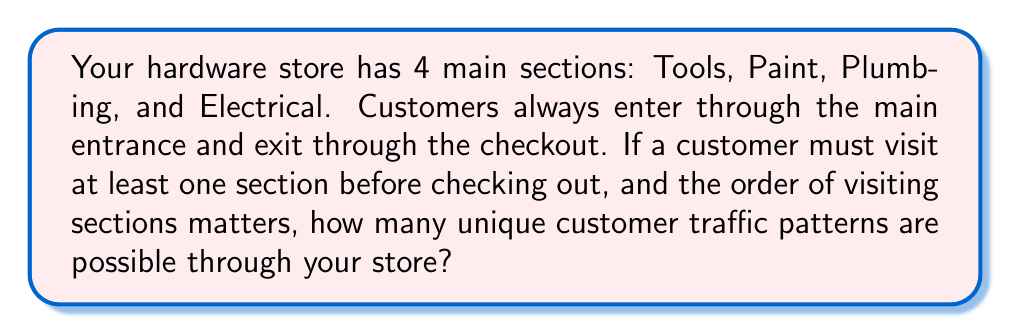Help me with this question. Let's approach this step-by-step:

1) First, we need to understand what constitutes a valid pattern:
   - It must start at the entrance
   - It must include at least one section
   - It can include any number of sections from 1 to 4
   - The order of sections visited matters
   - It must end at the checkout

2) Now, let's count the patterns:

   - Patterns with 1 section: There are 4 choices (4C1 = 4)
   - Patterns with 2 sections: There are 4 choices for the first and 3 for the second (4P2 = 4 * 3 = 12)
   - Patterns with 3 sections: 4P3 = 4 * 3 * 2 = 24
   - Patterns with 4 sections: 4! = 4 * 3 * 2 * 1 = 24

3) The total number of patterns is the sum of all these possibilities:

   $$ \text{Total patterns} = 4 + 12 + 24 + 24 = 64 $$

4) We can also express this using the summation notation:

   $$ \sum_{k=1}^{4} P(4,k) = P(4,1) + P(4,2) + P(4,3) + P(4,4) = 64 $$

   Where $P(n,k)$ represents the number of k-permutations of n elements.

Thus, there are 64 unique customer traffic patterns possible through your store layout.
Answer: 64 unique patterns 